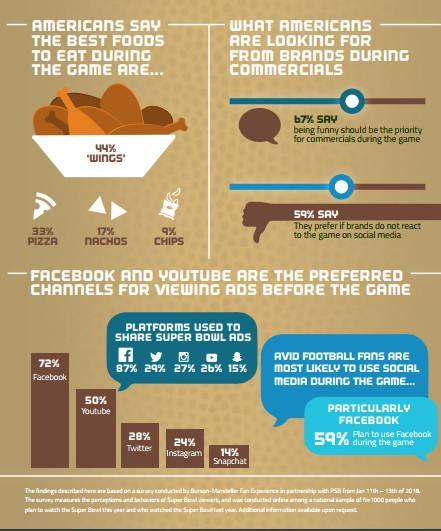What percent of super bowl ads are shared on Facebook?
Answer the question with a short phrase. 87% What percent of people say nachos are the best to eat while watching the game? 17% How many of the people prefer Instagram for viewing ads before the game? 24% What percent of Americans prefer pizza to eat while watching the game? 33% 